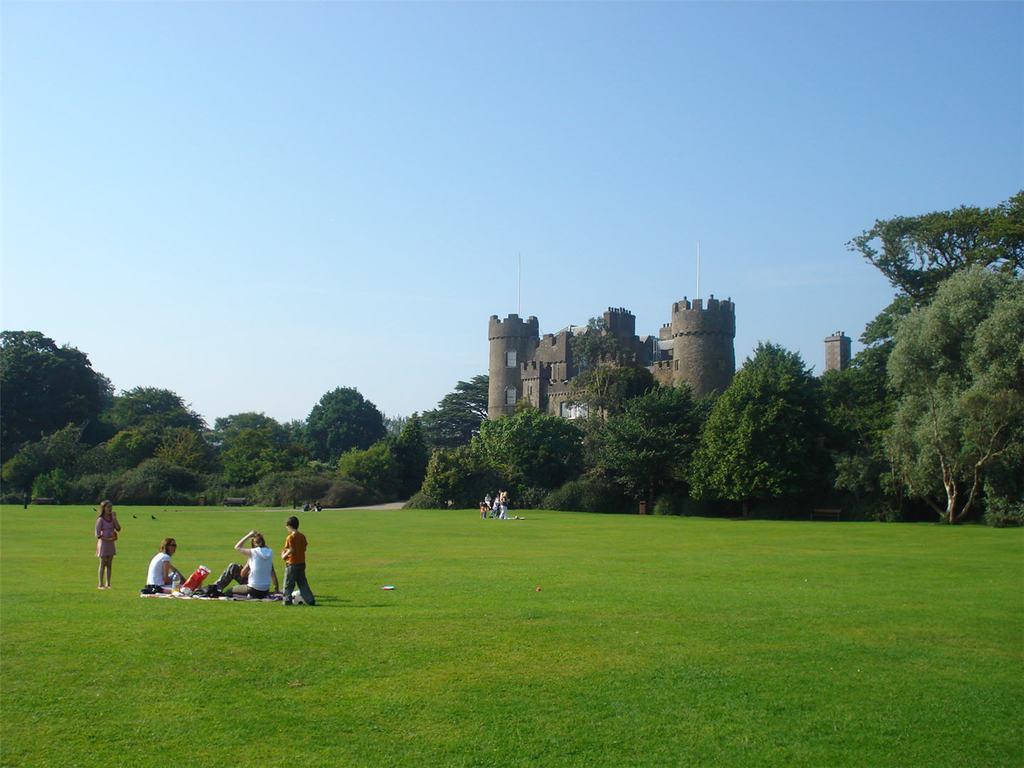Could you give a brief overview of what you see in this image? There are two people sitting and two people standing. This looks like a castle. These are the trees. Here is the grass. I can see a group of people. This is the sky. 